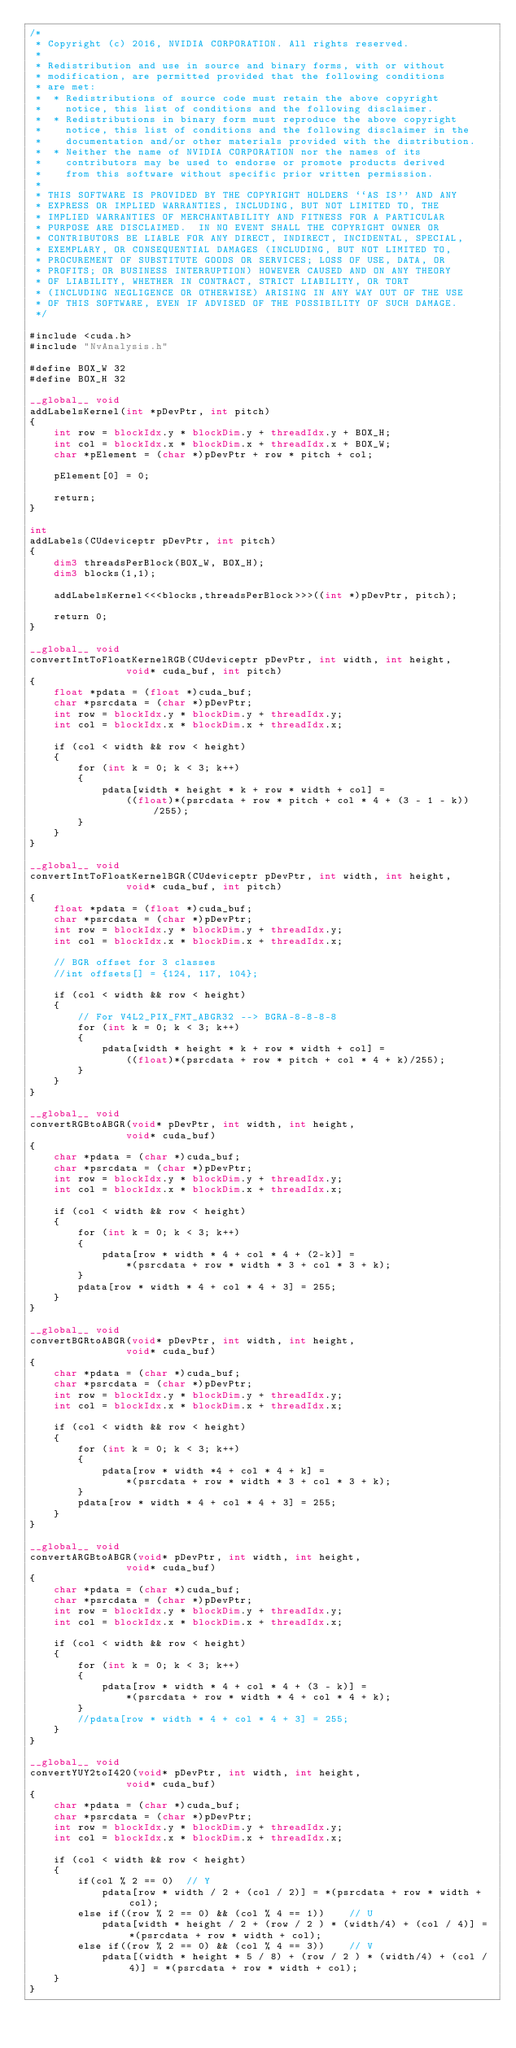<code> <loc_0><loc_0><loc_500><loc_500><_Cuda_>/*
 * Copyright (c) 2016, NVIDIA CORPORATION. All rights reserved.
 *
 * Redistribution and use in source and binary forms, with or without
 * modification, are permitted provided that the following conditions
 * are met:
 *  * Redistributions of source code must retain the above copyright
 *    notice, this list of conditions and the following disclaimer.
 *  * Redistributions in binary form must reproduce the above copyright
 *    notice, this list of conditions and the following disclaimer in the
 *    documentation and/or other materials provided with the distribution.
 *  * Neither the name of NVIDIA CORPORATION nor the names of its
 *    contributors may be used to endorse or promote products derived
 *    from this software without specific prior written permission.
 *
 * THIS SOFTWARE IS PROVIDED BY THE COPYRIGHT HOLDERS ``AS IS'' AND ANY
 * EXPRESS OR IMPLIED WARRANTIES, INCLUDING, BUT NOT LIMITED TO, THE
 * IMPLIED WARRANTIES OF MERCHANTABILITY AND FITNESS FOR A PARTICULAR
 * PURPOSE ARE DISCLAIMED.  IN NO EVENT SHALL THE COPYRIGHT OWNER OR
 * CONTRIBUTORS BE LIABLE FOR ANY DIRECT, INDIRECT, INCIDENTAL, SPECIAL,
 * EXEMPLARY, OR CONSEQUENTIAL DAMAGES (INCLUDING, BUT NOT LIMITED TO,
 * PROCUREMENT OF SUBSTITUTE GOODS OR SERVICES; LOSS OF USE, DATA, OR
 * PROFITS; OR BUSINESS INTERRUPTION) HOWEVER CAUSED AND ON ANY THEORY
 * OF LIABILITY, WHETHER IN CONTRACT, STRICT LIABILITY, OR TORT
 * (INCLUDING NEGLIGENCE OR OTHERWISE) ARISING IN ANY WAY OUT OF THE USE
 * OF THIS SOFTWARE, EVEN IF ADVISED OF THE POSSIBILITY OF SUCH DAMAGE.
 */

#include <cuda.h>
#include "NvAnalysis.h"

#define BOX_W 32
#define BOX_H 32

__global__ void
addLabelsKernel(int *pDevPtr, int pitch)
{
    int row = blockIdx.y * blockDim.y + threadIdx.y + BOX_H;
    int col = blockIdx.x * blockDim.x + threadIdx.x + BOX_W;
    char *pElement = (char *)pDevPtr + row * pitch + col;

    pElement[0] = 0;

    return;
}

int 
addLabels(CUdeviceptr pDevPtr, int pitch)
{
    dim3 threadsPerBlock(BOX_W, BOX_H);
    dim3 blocks(1,1);

    addLabelsKernel<<<blocks,threadsPerBlock>>>((int *)pDevPtr, pitch);

    return 0;
}

__global__ void
convertIntToFloatKernelRGB(CUdeviceptr pDevPtr, int width, int height,
                void* cuda_buf, int pitch)
{
    float *pdata = (float *)cuda_buf;
    char *psrcdata = (char *)pDevPtr;
    int row = blockIdx.y * blockDim.y + threadIdx.y;
    int col = blockIdx.x * blockDim.x + threadIdx.x;

    if (col < width && row < height)
    {
        for (int k = 0; k < 3; k++)
        {
            pdata[width * height * k + row * width + col] =
                ((float)*(psrcdata + row * pitch + col * 4 + (3 - 1 - k))/255);
        }
    }
}

__global__ void
convertIntToFloatKernelBGR(CUdeviceptr pDevPtr, int width, int height,
                void* cuda_buf, int pitch)
{
    float *pdata = (float *)cuda_buf;
    char *psrcdata = (char *)pDevPtr;
    int row = blockIdx.y * blockDim.y + threadIdx.y;
    int col = blockIdx.x * blockDim.x + threadIdx.x;

    // BGR offset for 3 classes
    //int offsets[] = {124, 117, 104};

    if (col < width && row < height)
    {
        // For V4L2_PIX_FMT_ABGR32 --> BGRA-8-8-8-8
        for (int k = 0; k < 3; k++)
        {
            pdata[width * height * k + row * width + col] =
                ((float)*(psrcdata + row * pitch + col * 4 + k)/255);
        }
    }
}

__global__ void
convertRGBtoABGR(void* pDevPtr, int width, int height,
                void* cuda_buf)
{
    char *pdata = (char *)cuda_buf;
    char *psrcdata = (char *)pDevPtr;
    int row = blockIdx.y * blockDim.y + threadIdx.y;
    int col = blockIdx.x * blockDim.x + threadIdx.x;

    if (col < width && row < height)
    {
        for (int k = 0; k < 3; k++)
        {
            pdata[row * width * 4 + col * 4 + (2-k)] =
                *(psrcdata + row * width * 3 + col * 3 + k);
        }
		pdata[row * width * 4 + col * 4 + 3] = 255;
    }
}

__global__ void
convertBGRtoABGR(void* pDevPtr, int width, int height,
                void* cuda_buf)
{
    char *pdata = (char *)cuda_buf;
    char *psrcdata = (char *)pDevPtr;
    int row = blockIdx.y * blockDim.y + threadIdx.y;
    int col = blockIdx.x * blockDim.x + threadIdx.x;

    if (col < width && row < height)
    {
        for (int k = 0; k < 3; k++)
        {
            pdata[row * width *4 + col * 4 + k] =
                *(psrcdata + row * width * 3 + col * 3 + k);
        }
		pdata[row * width * 4 + col * 4 + 3] = 255;
    }
}

__global__ void
convertARGBtoABGR(void* pDevPtr, int width, int height,
                void* cuda_buf)
{
    char *pdata = (char *)cuda_buf;
    char *psrcdata = (char *)pDevPtr;
    int row = blockIdx.y * blockDim.y + threadIdx.y;
    int col = blockIdx.x * blockDim.x + threadIdx.x;

    if (col < width && row < height)
    {
        for (int k = 0; k < 3; k++)
        {
            pdata[row * width * 4 + col * 4 + (3 - k)] =
                *(psrcdata + row * width * 4 + col * 4 + k);
        }
		//pdata[row * width * 4 + col * 4 + 3] = 255;
    }
}

__global__ void
convertYUY2toI420(void* pDevPtr, int width, int height,
                void* cuda_buf)
{
    char *pdata = (char *)cuda_buf;
    char *psrcdata = (char *)pDevPtr;
    int row = blockIdx.y * blockDim.y + threadIdx.y;
    int col = blockIdx.x * blockDim.x + threadIdx.x;

    if (col < width && row < height)
    {
        if(col % 2 == 0)  // Y
            pdata[row * width / 2 + (col / 2)] = *(psrcdata + row * width + col);
        else if((row % 2 == 0) && (col % 4 == 1))    // U
            pdata[width * height / 2 + (row / 2 ) * (width/4) + (col / 4)] = *(psrcdata + row * width + col);
        else if((row % 2 == 0) && (col % 4 == 3))    // V
            pdata[(width * height * 5 / 8) + (row / 2 ) * (width/4) + (col / 4)] = *(psrcdata + row * width + col);        
    } 
}
</code> 